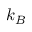Convert formula to latex. <formula><loc_0><loc_0><loc_500><loc_500>k _ { B }</formula> 